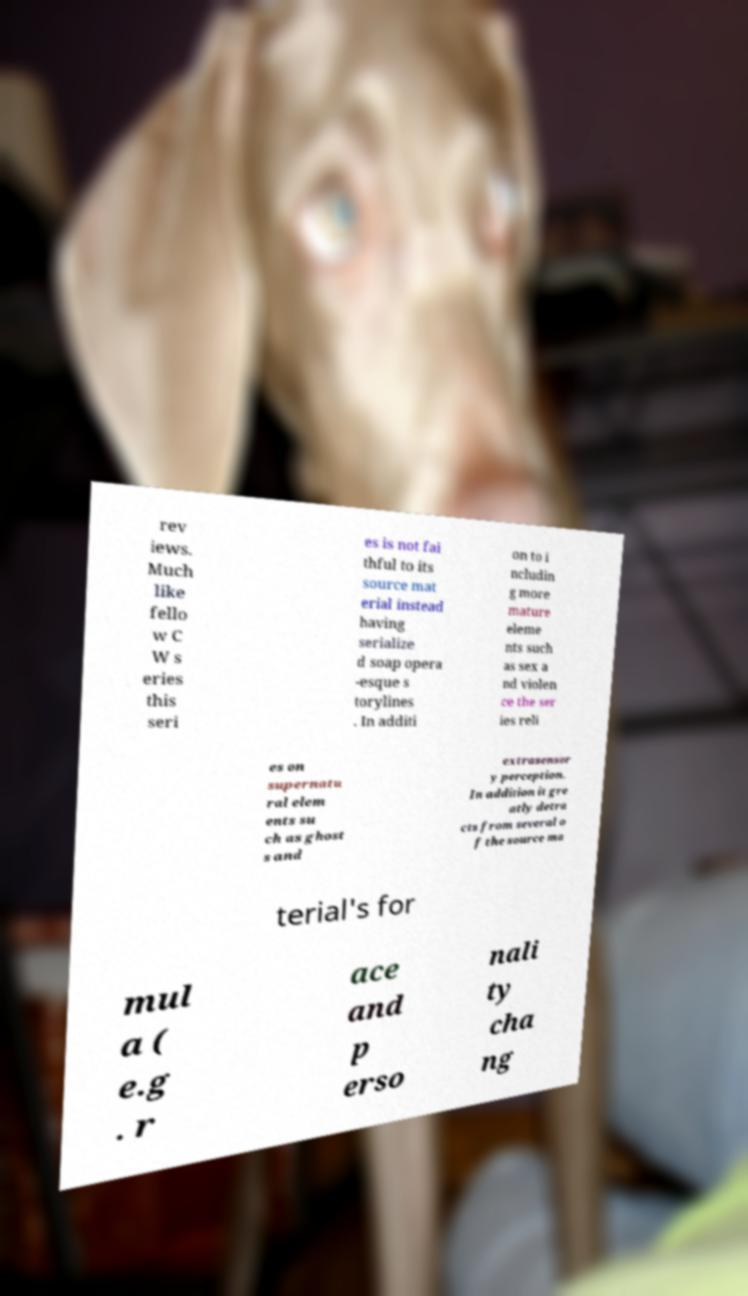Can you read and provide the text displayed in the image?This photo seems to have some interesting text. Can you extract and type it out for me? rev iews. Much like fello w C W s eries this seri es is not fai thful to its source mat erial instead having serialize d soap opera -esque s torylines . In additi on to i ncludin g more mature eleme nts such as sex a nd violen ce the ser ies reli es on supernatu ral elem ents su ch as ghost s and extrasensor y perception. In addition it gre atly detra cts from several o f the source ma terial's for mul a ( e.g . r ace and p erso nali ty cha ng 